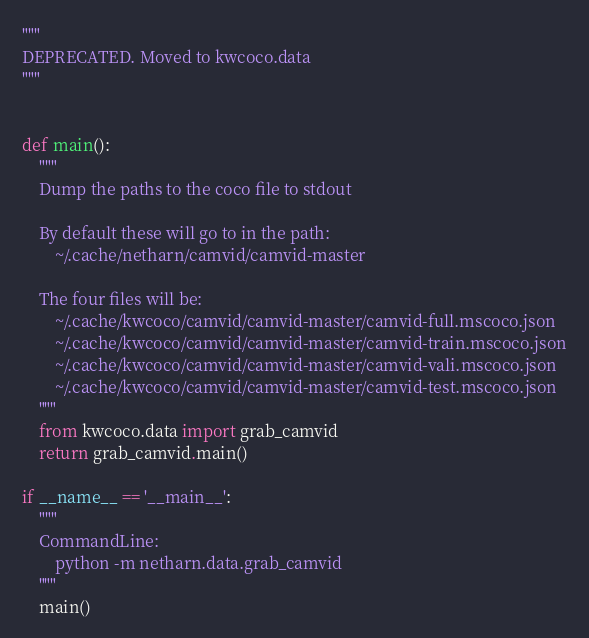Convert code to text. <code><loc_0><loc_0><loc_500><loc_500><_Python_>"""
DEPRECATED. Moved to kwcoco.data
"""


def main():
    """
    Dump the paths to the coco file to stdout

    By default these will go to in the path:
        ~/.cache/netharn/camvid/camvid-master

    The four files will be:
        ~/.cache/kwcoco/camvid/camvid-master/camvid-full.mscoco.json
        ~/.cache/kwcoco/camvid/camvid-master/camvid-train.mscoco.json
        ~/.cache/kwcoco/camvid/camvid-master/camvid-vali.mscoco.json
        ~/.cache/kwcoco/camvid/camvid-master/camvid-test.mscoco.json
    """
    from kwcoco.data import grab_camvid
    return grab_camvid.main()

if __name__ == '__main__':
    """
    CommandLine:
        python -m netharn.data.grab_camvid
    """
    main()
</code> 